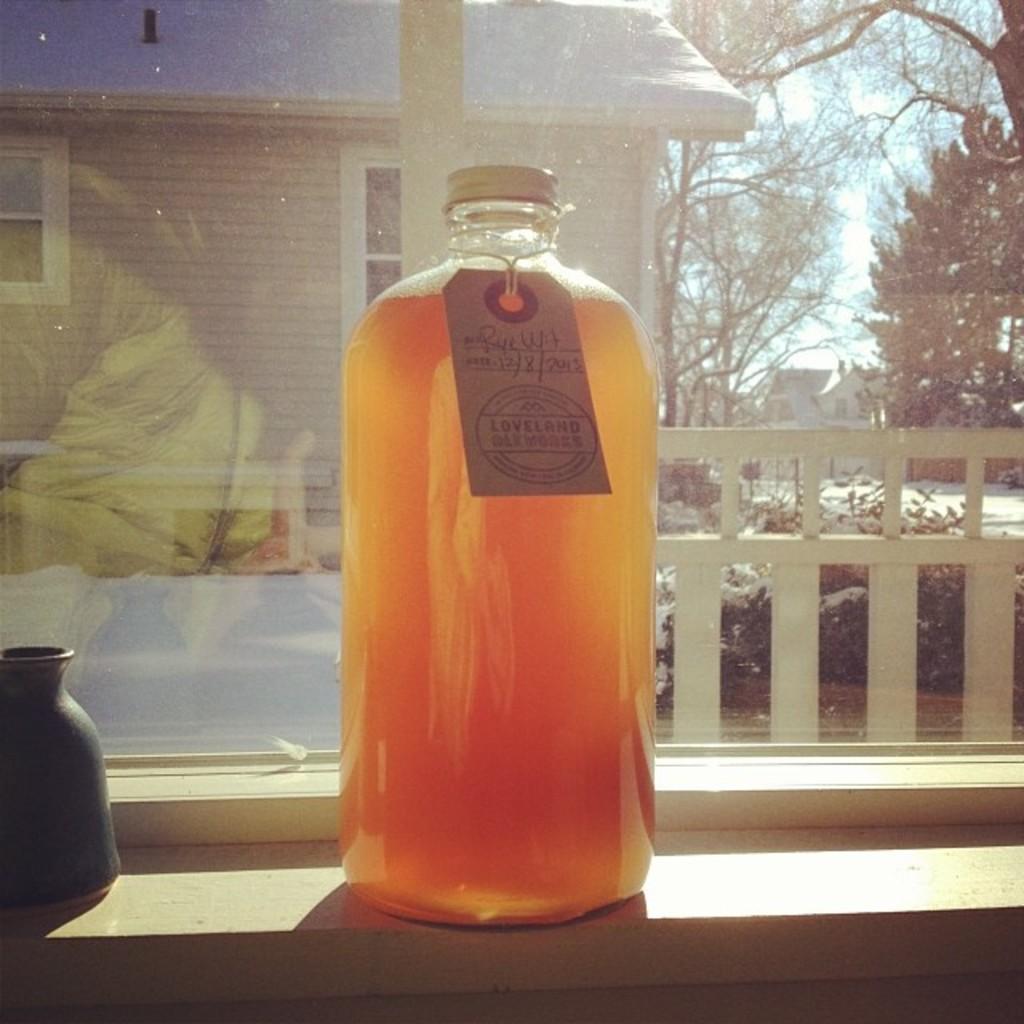What date is written on the label?
Offer a terse response. 12/8/2013. 